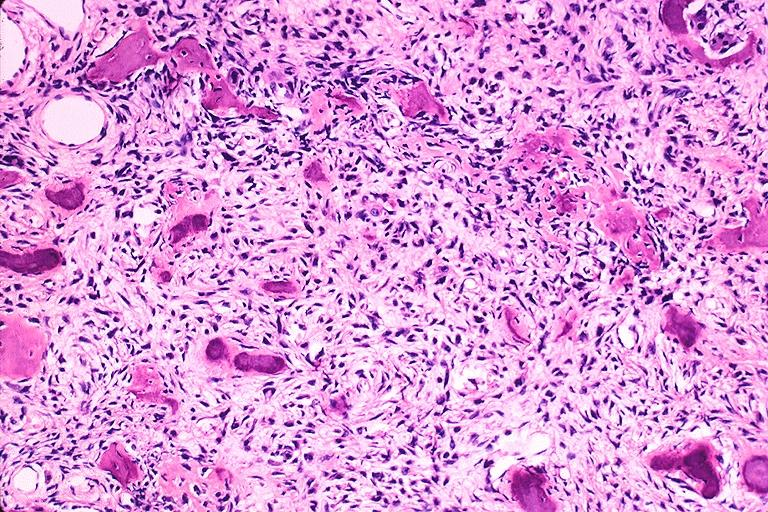where is this?
Answer the question using a single word or phrase. Oral 